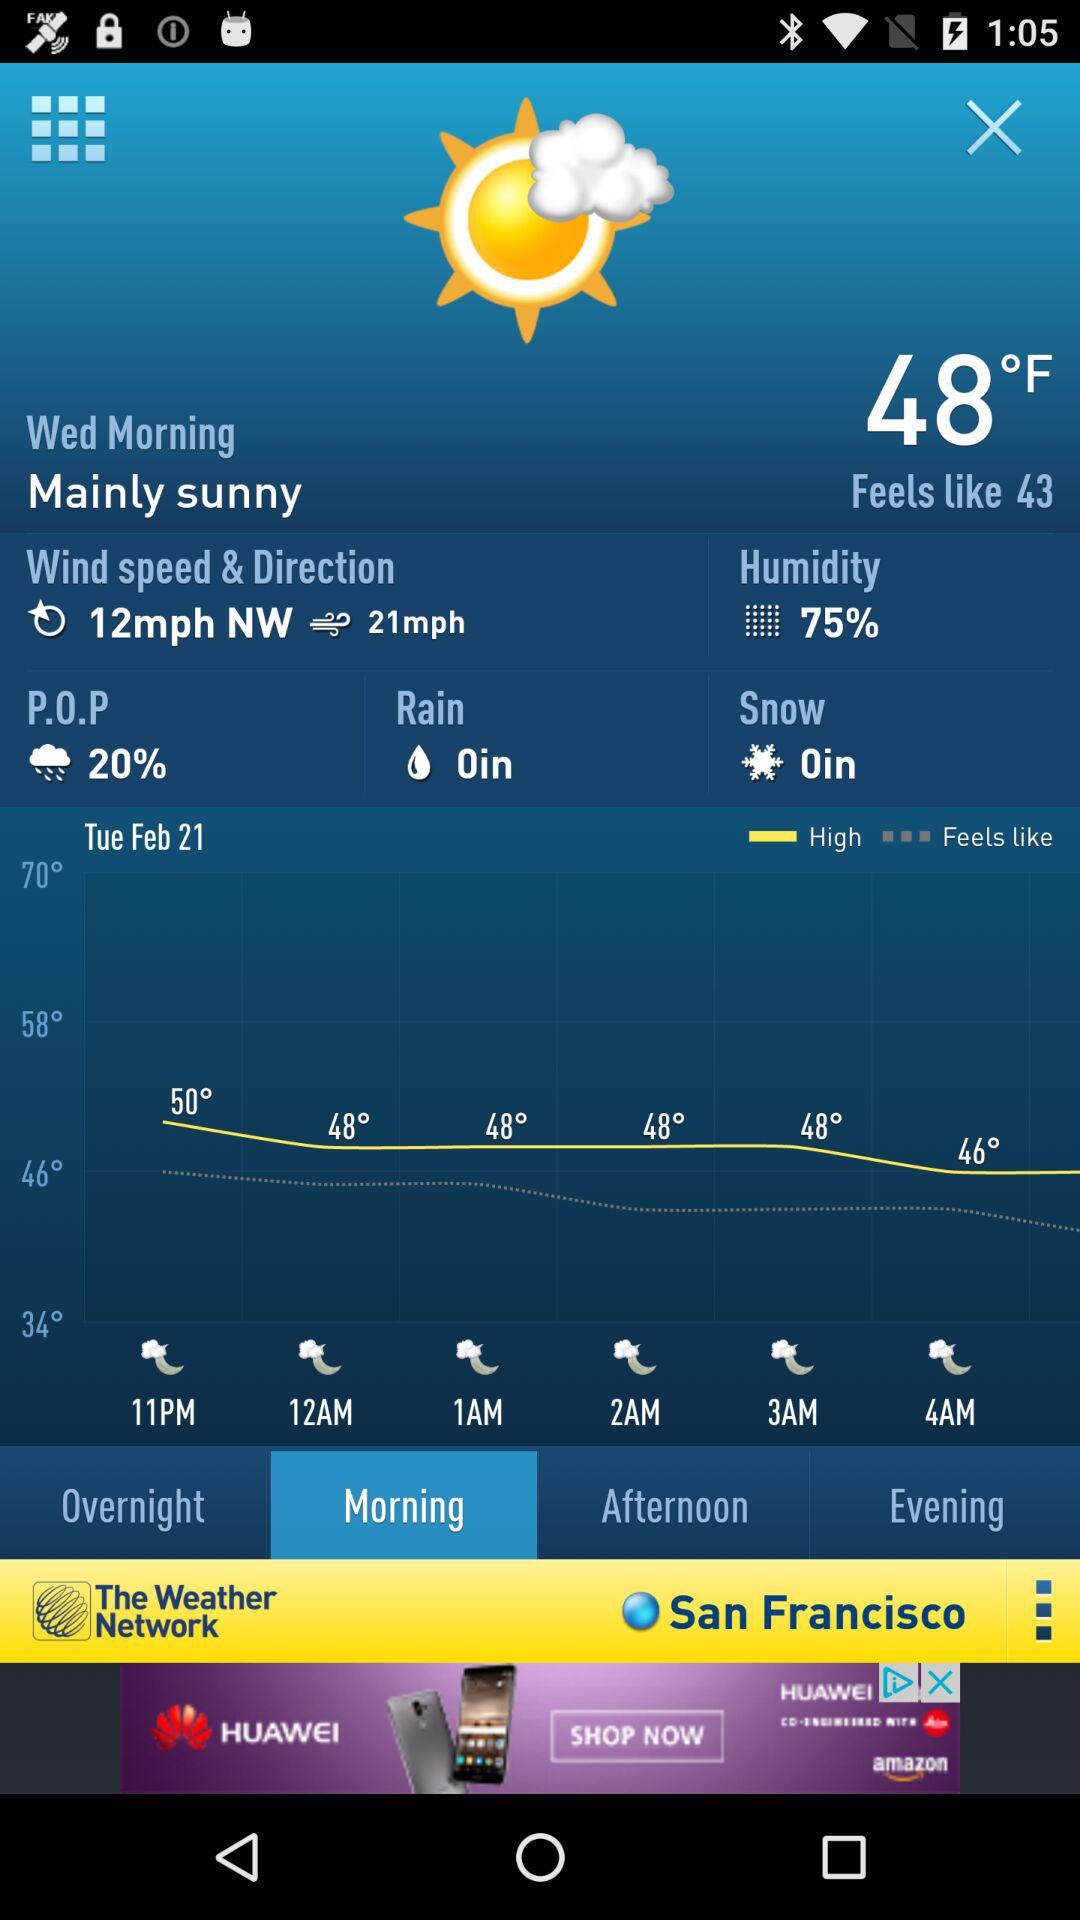What is the location? The location is San Francisco. 